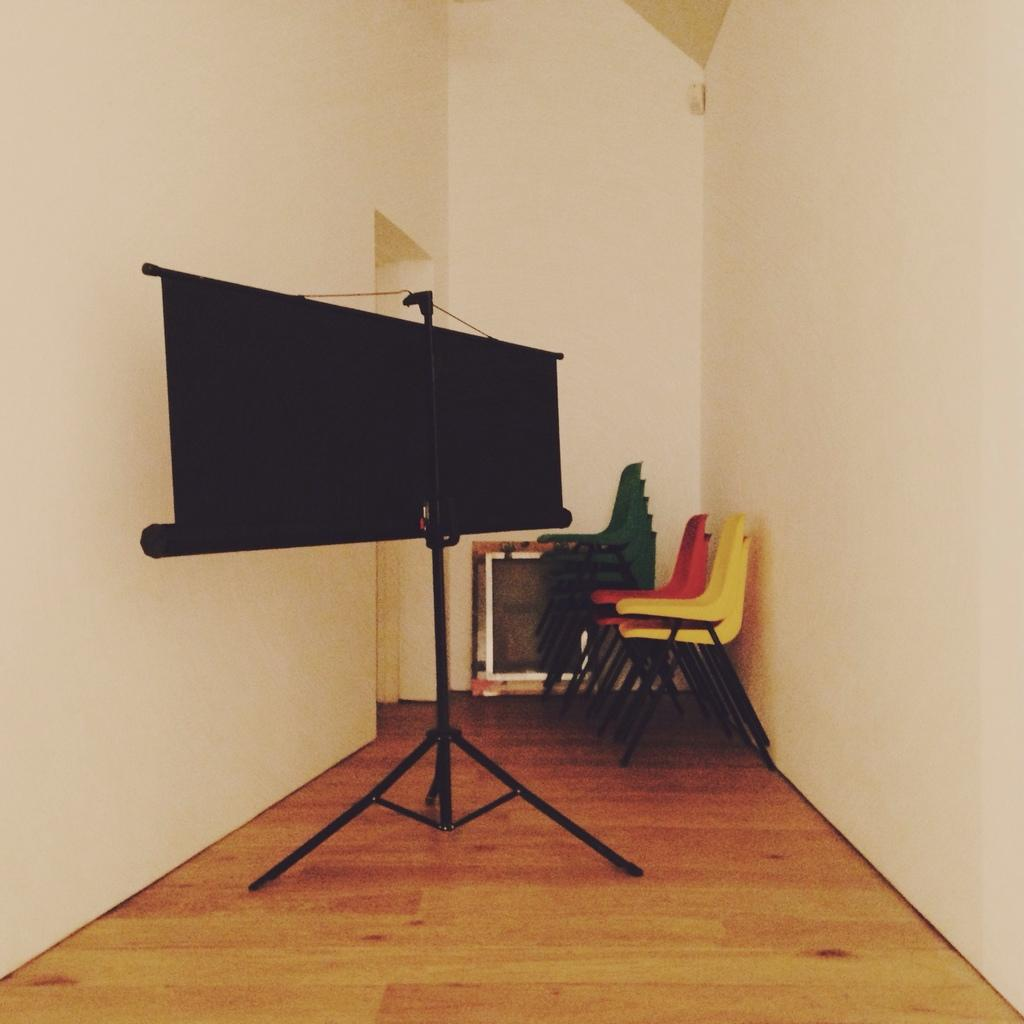What is the main object in the image? There is a projector screen in the image. What is supporting the projector screen? There is a tripod stand in the image. What type of furniture is present in the image? Chairs are visible in the image. What type of structure is visible in the image? There are walls in the image. What is the board used for in the image? There is a board in the image, but its purpose is not clear from the provided facts. What historical event is being discussed in the image? There is no indication of a historical event being discussed in the image. The image only shows a projector screen, tripod stand, chairs, walls, and a board. 